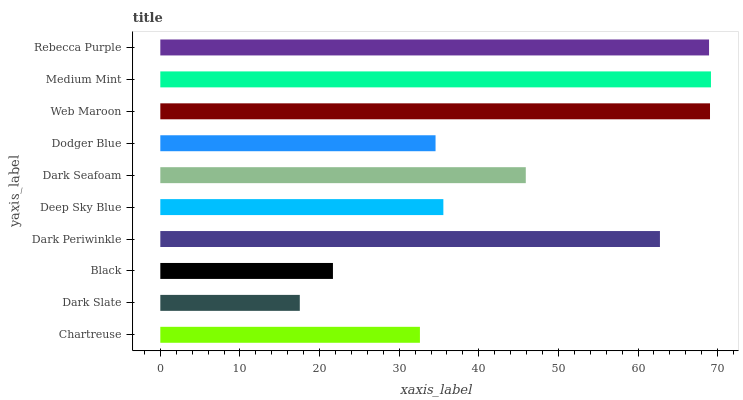Is Dark Slate the minimum?
Answer yes or no. Yes. Is Medium Mint the maximum?
Answer yes or no. Yes. Is Black the minimum?
Answer yes or no. No. Is Black the maximum?
Answer yes or no. No. Is Black greater than Dark Slate?
Answer yes or no. Yes. Is Dark Slate less than Black?
Answer yes or no. Yes. Is Dark Slate greater than Black?
Answer yes or no. No. Is Black less than Dark Slate?
Answer yes or no. No. Is Dark Seafoam the high median?
Answer yes or no. Yes. Is Deep Sky Blue the low median?
Answer yes or no. Yes. Is Dodger Blue the high median?
Answer yes or no. No. Is Dodger Blue the low median?
Answer yes or no. No. 